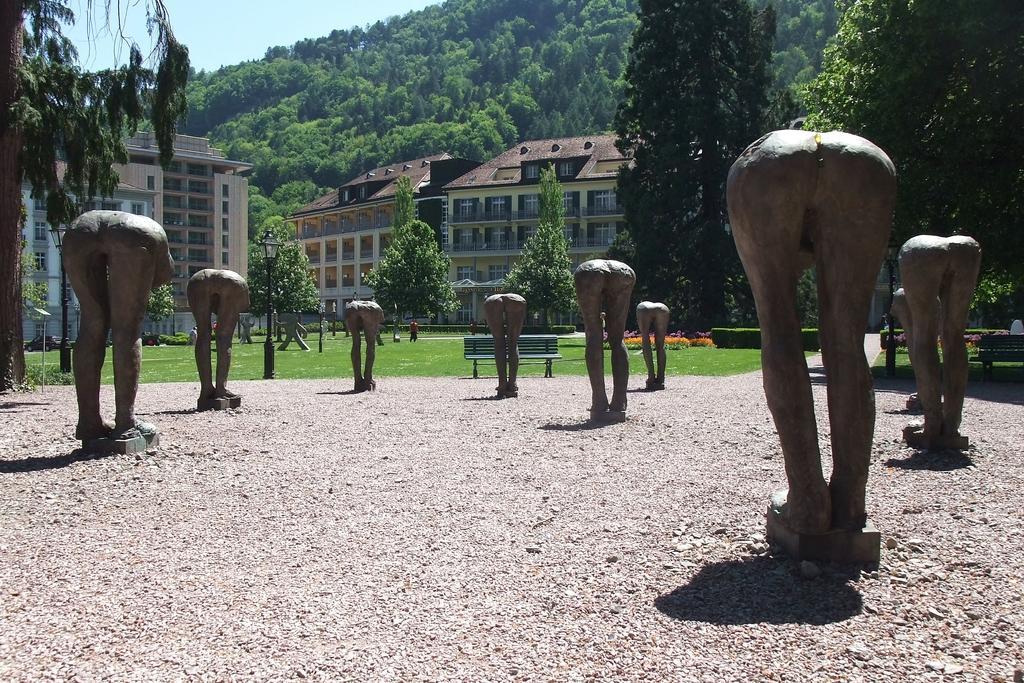Describe this image in one or two sentences. This is an outside view. Here I can see few statues of persons. In the background there are many buildings and trees. At the top of the image I can see the sky. In the middle of the image there is a bench placed on the ground. 